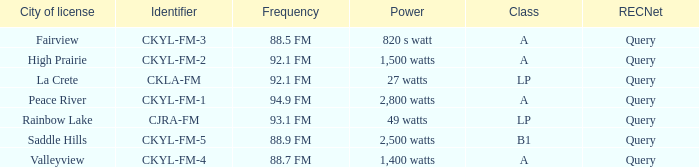What is the frequency that has a fairview city of license 88.5 FM. 